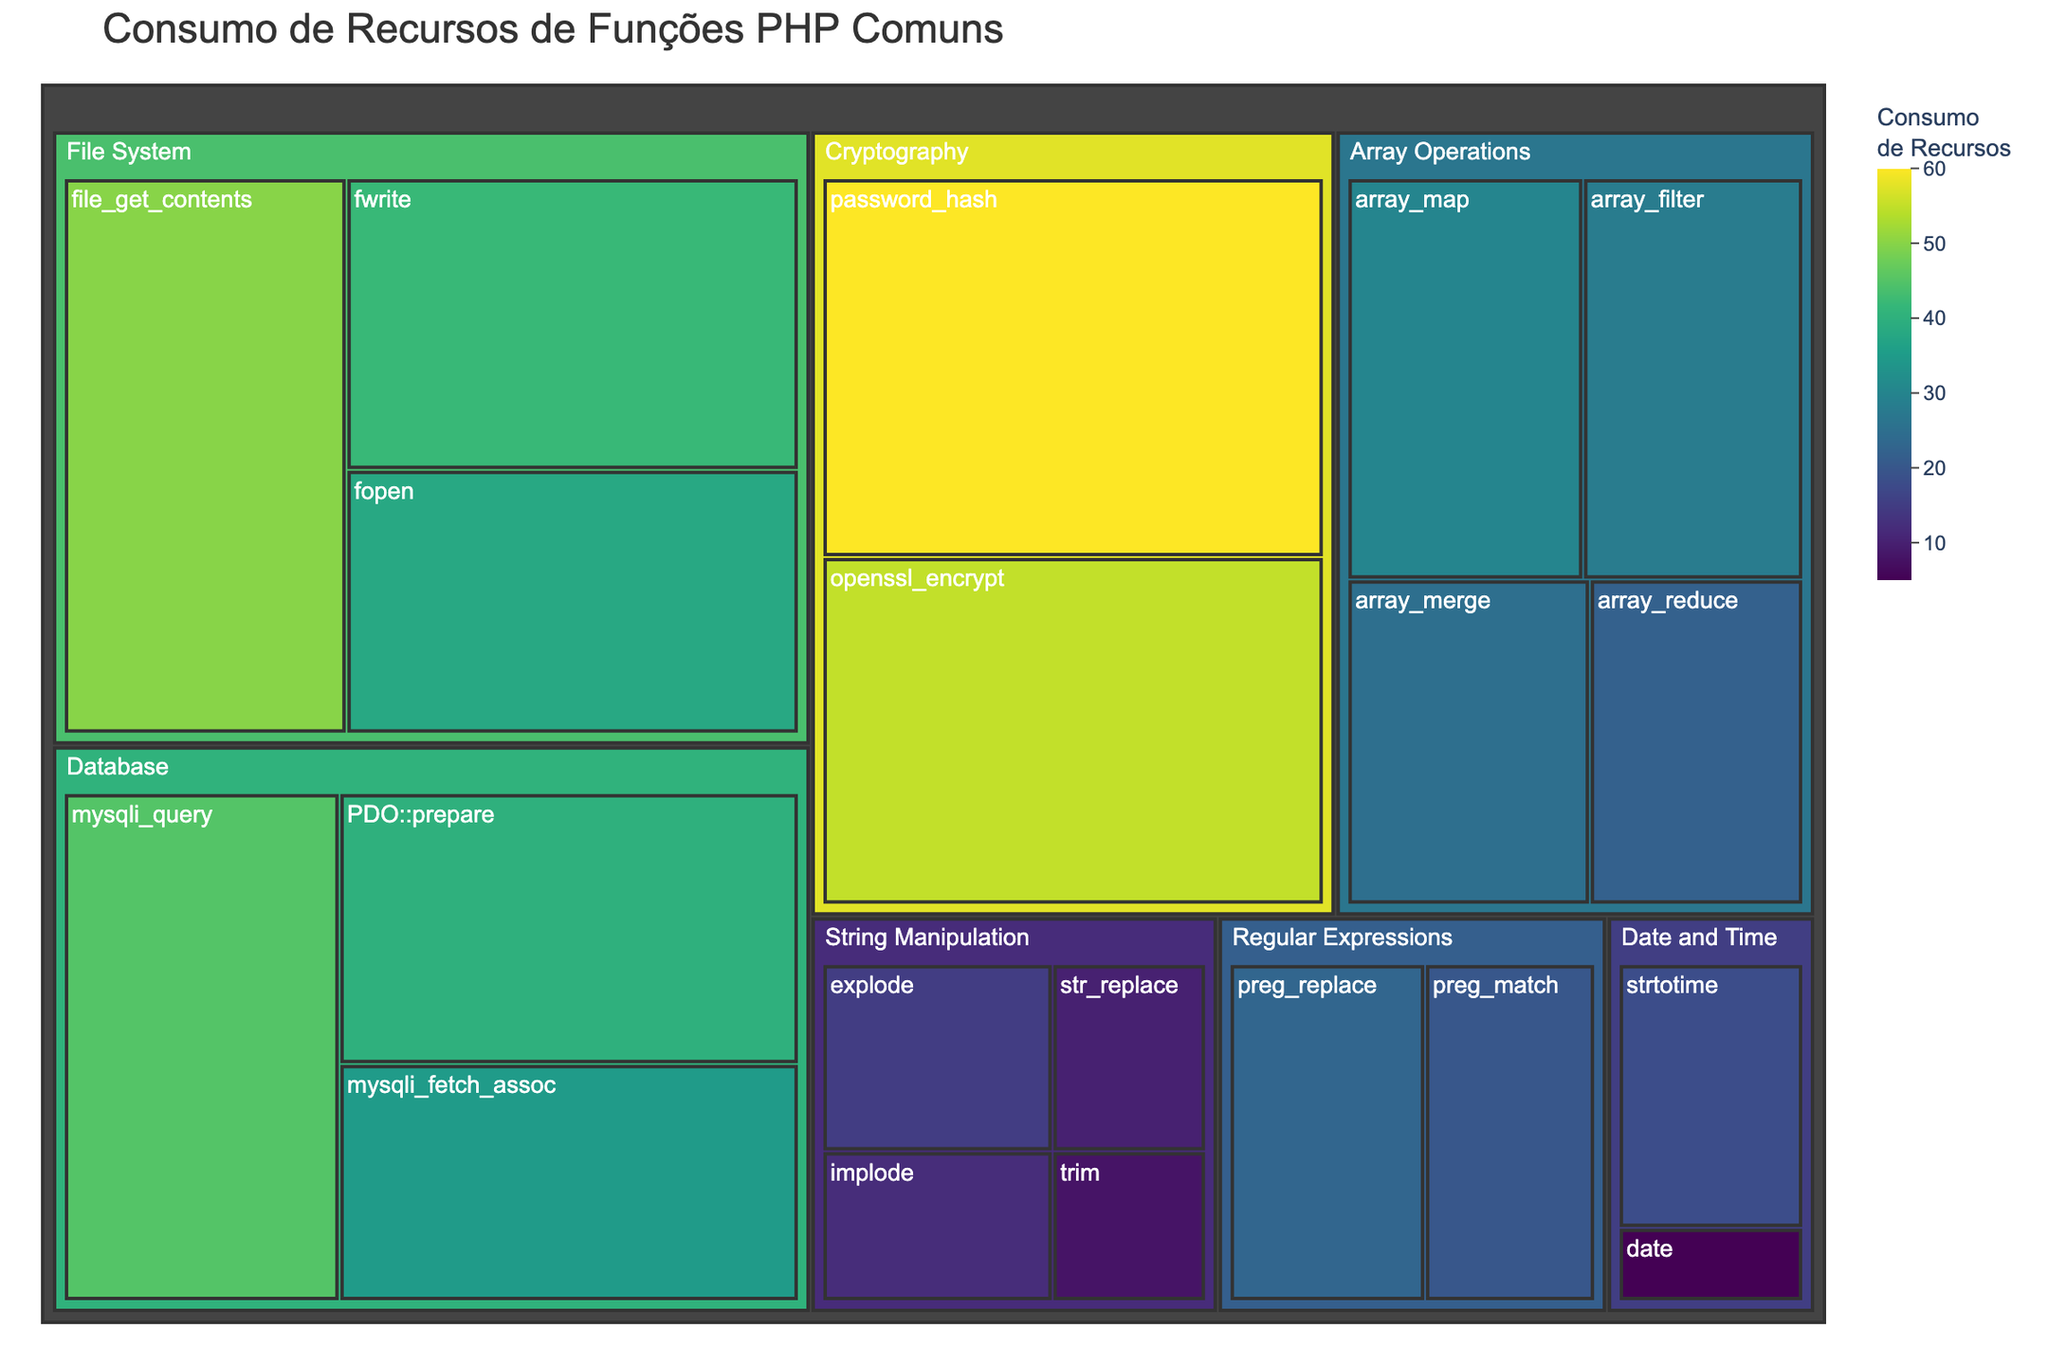What is the title of the treemap? The title is located at the top of the treemap and is prominently displayed.
Answer: Consumo de Recursos de Funções PHP Comuns Which category has the function with the highest resource consumption? The function with the highest resource consumption is in the Cryptography category, specifically the password_hash function with a consumption value of 60.
Answer: Cryptography Between 'array_filter' and 'array_reduce', which function consumes more resources and by how much? Array_filter has a resource consumption of 28, whereas array_reduce has 22, therefore array_filter consumes 6 more resources than array_reduce.
Answer: Array_filter by 6 What is the total resource consumption of all database-related functions? To get the total resource consumption, sum the values of all database functions: 45 (mysqli_query) + 40 (PDO::prepare) + 35 (mysqli_fetch_assoc) = 120.
Answer: 120 Which string manipulation function has the lowest resource consumption? Among string manipulation functions, the 'trim' function has the lowest value at 8.
Answer: trim How does the resource consumption of 'fwrite' compare to 'mysqli_query'? Fwrite consumes 42 resources, whereas mysqli_query consumes 45, meaning fwrite consumes 3 fewer resources.
Answer: Fwrite consumes 3 fewer resources What is the average resource consumption of array operations? Sum the resource consumption values of all array operations and divide by the number of functions: (25 + 30 + 28 + 22) / 4 = 26.25.
Answer: 26.25 Which category contains more resource-intensive functions: File System or Database? The sum of resource consumption for File System is 50 (file_get_contents) + 38 (fopen) + 42 (fwrite) = 130. The sum for Database is 45 (mysqli_query) + 40 (PDO::prepare) + 35 (mysqli_fetch_assoc) = 120. File System has a higher total.
Answer: File System What is the difference in resource consumption between the most and least resource-intensive functions? The highest resource consumption is 60 (password_hash) and the lowest is 5 (date). The difference is 60 - 5 = 55.
Answer: 55 Among the regular expressions functions, which one consumes slightly more resources? Comparing preg_match (20) and preg_replace (23), preg_replace consumes slightly more resources.
Answer: preg_replace 